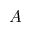Convert formula to latex. <formula><loc_0><loc_0><loc_500><loc_500>A</formula> 